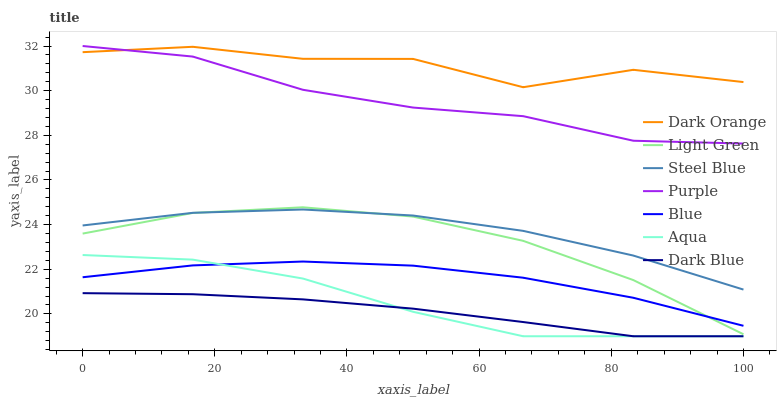Does Dark Blue have the minimum area under the curve?
Answer yes or no. Yes. Does Dark Orange have the maximum area under the curve?
Answer yes or no. Yes. Does Purple have the minimum area under the curve?
Answer yes or no. No. Does Purple have the maximum area under the curve?
Answer yes or no. No. Is Dark Blue the smoothest?
Answer yes or no. Yes. Is Dark Orange the roughest?
Answer yes or no. Yes. Is Purple the smoothest?
Answer yes or no. No. Is Purple the roughest?
Answer yes or no. No. Does Aqua have the lowest value?
Answer yes or no. Yes. Does Purple have the lowest value?
Answer yes or no. No. Does Purple have the highest value?
Answer yes or no. Yes. Does Dark Orange have the highest value?
Answer yes or no. No. Is Dark Blue less than Light Green?
Answer yes or no. Yes. Is Dark Orange greater than Aqua?
Answer yes or no. Yes. Does Dark Blue intersect Aqua?
Answer yes or no. Yes. Is Dark Blue less than Aqua?
Answer yes or no. No. Is Dark Blue greater than Aqua?
Answer yes or no. No. Does Dark Blue intersect Light Green?
Answer yes or no. No. 